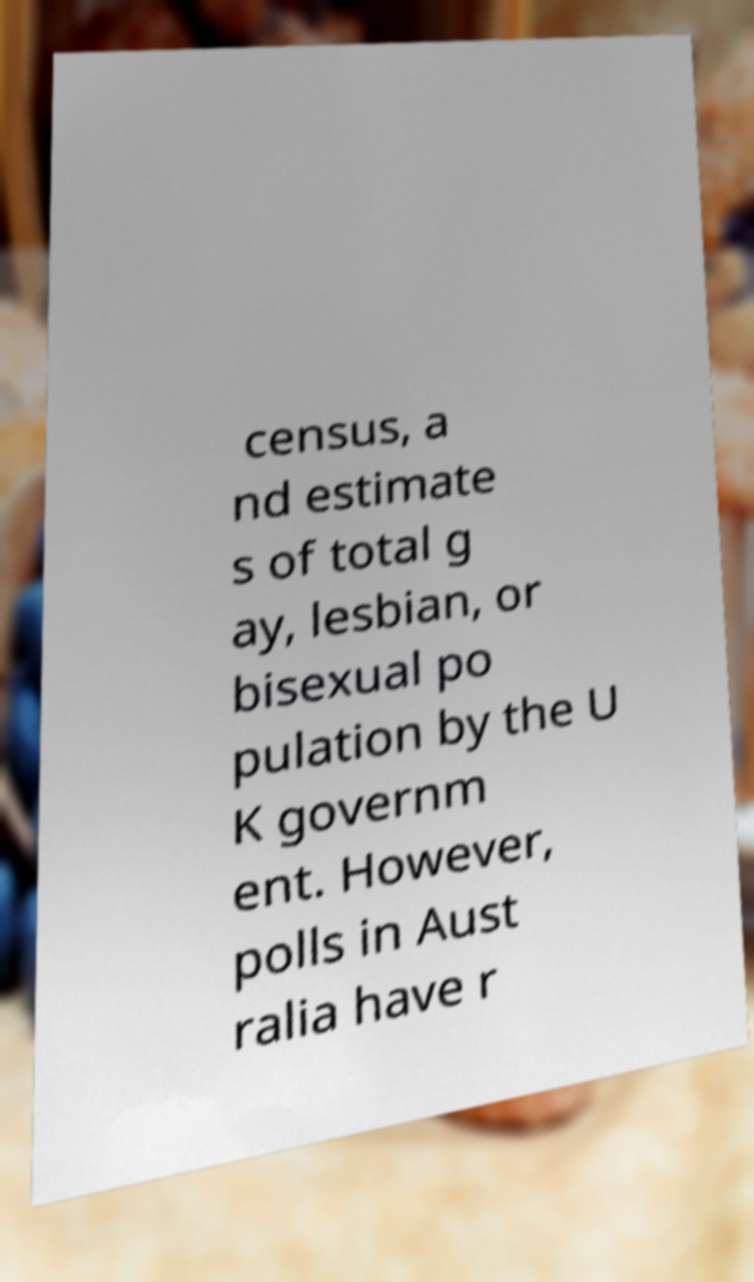Please identify and transcribe the text found in this image. census, a nd estimate s of total g ay, lesbian, or bisexual po pulation by the U K governm ent. However, polls in Aust ralia have r 